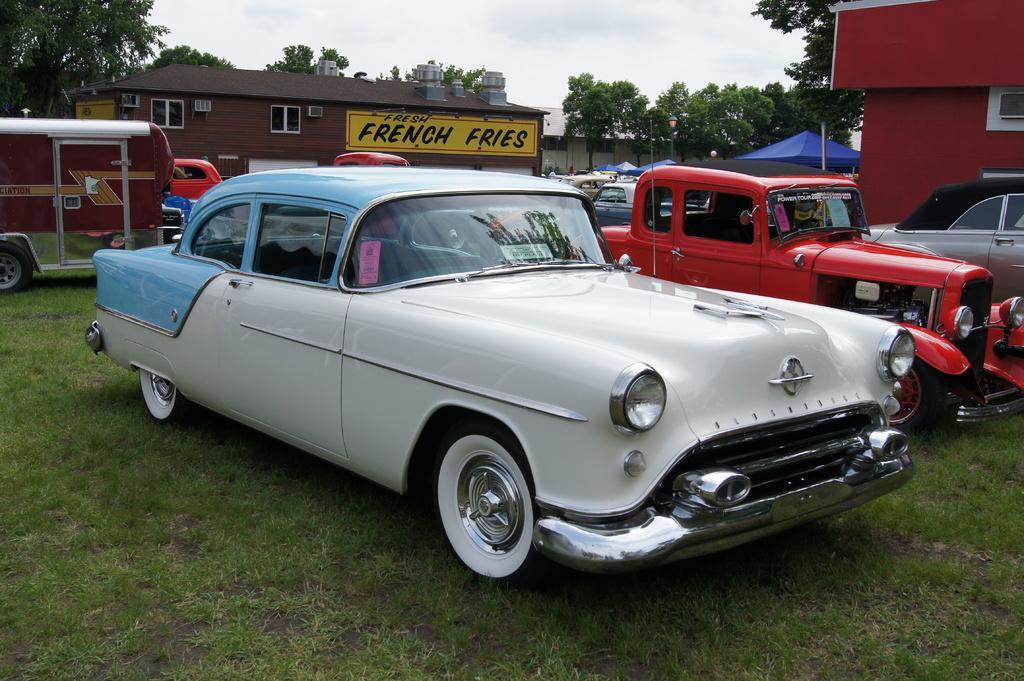Could you give a brief overview of what you see in this image? In this picture there is a white and blue old car parked on the green lawn. Beside there is a red color classic car. Behind there is a small restaurant shop on which "french fries'' is written. In the background there are some trees. 